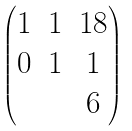<formula> <loc_0><loc_0><loc_500><loc_500>\begin{pmatrix} 1 & 1 & 1 8 \\ 0 & 1 & 1 \\ & & 6 \end{pmatrix}</formula> 